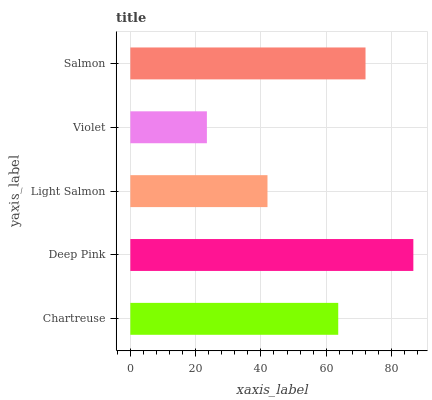Is Violet the minimum?
Answer yes or no. Yes. Is Deep Pink the maximum?
Answer yes or no. Yes. Is Light Salmon the minimum?
Answer yes or no. No. Is Light Salmon the maximum?
Answer yes or no. No. Is Deep Pink greater than Light Salmon?
Answer yes or no. Yes. Is Light Salmon less than Deep Pink?
Answer yes or no. Yes. Is Light Salmon greater than Deep Pink?
Answer yes or no. No. Is Deep Pink less than Light Salmon?
Answer yes or no. No. Is Chartreuse the high median?
Answer yes or no. Yes. Is Chartreuse the low median?
Answer yes or no. Yes. Is Light Salmon the high median?
Answer yes or no. No. Is Deep Pink the low median?
Answer yes or no. No. 